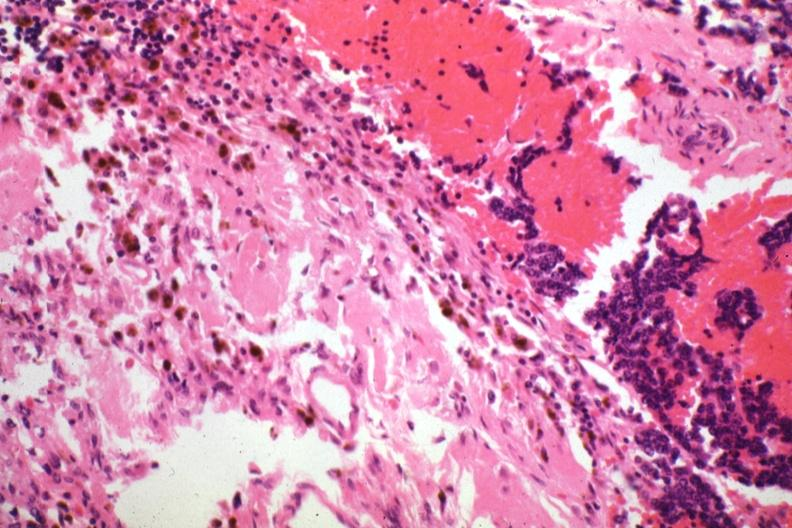how does this image show tissue about tumor?
Answer the question using a single word or phrase. With cells 